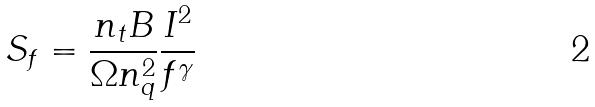Convert formula to latex. <formula><loc_0><loc_0><loc_500><loc_500>S _ { f } = \frac { n _ { t } B } { \Omega n _ { q } ^ { 2 } } \frac { I ^ { 2 } } { f ^ { \gamma } }</formula> 